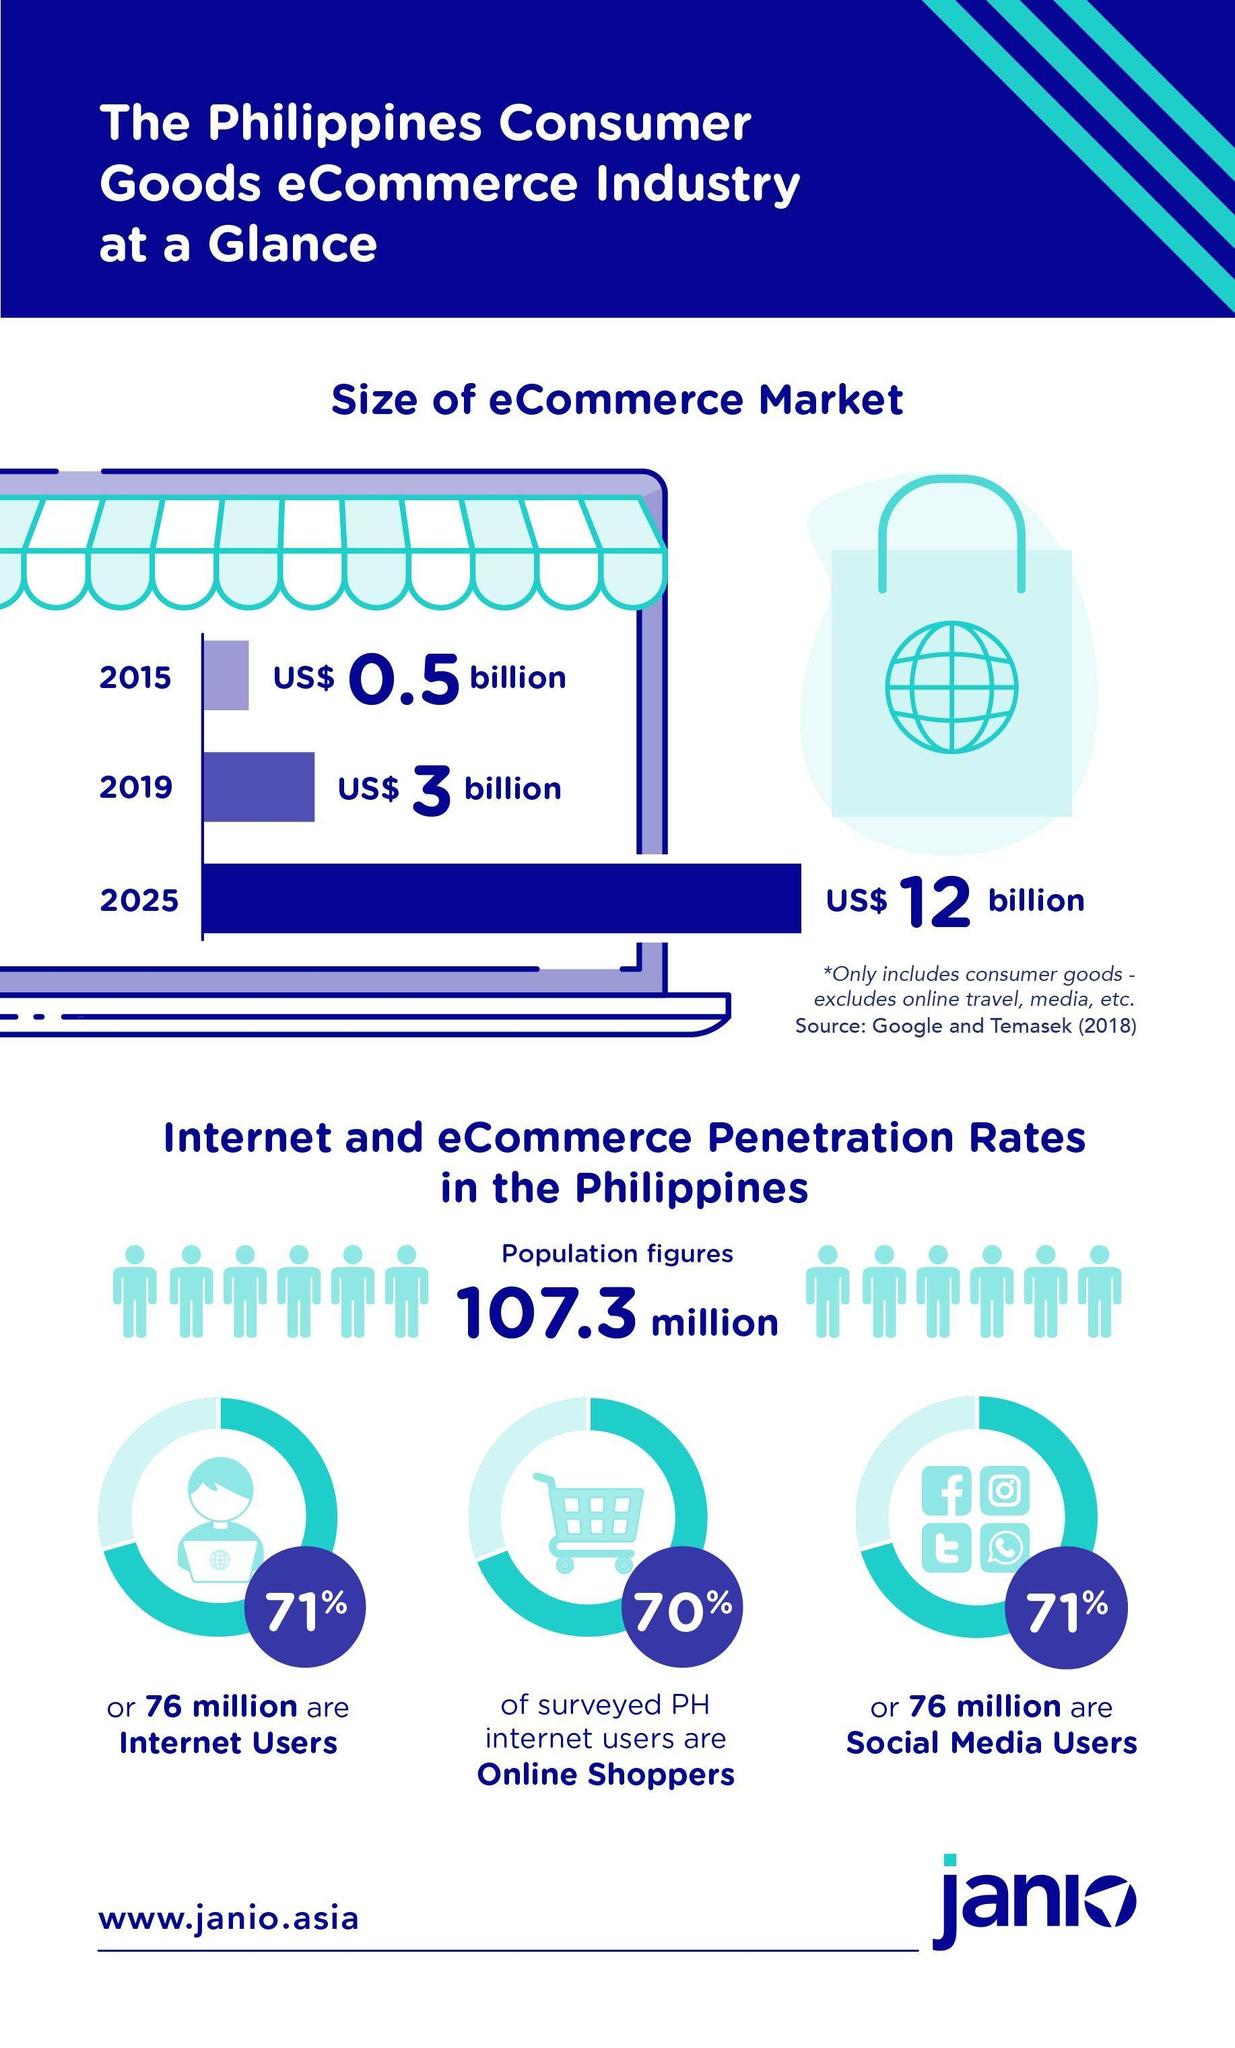How many social media users in Philippines?
Answer the question with a short phrase. 76 million What percentage of the population are social media users? 71% What percentage of the population are internet users? 71% What percentage of internet users are Online shoppers? 70% 